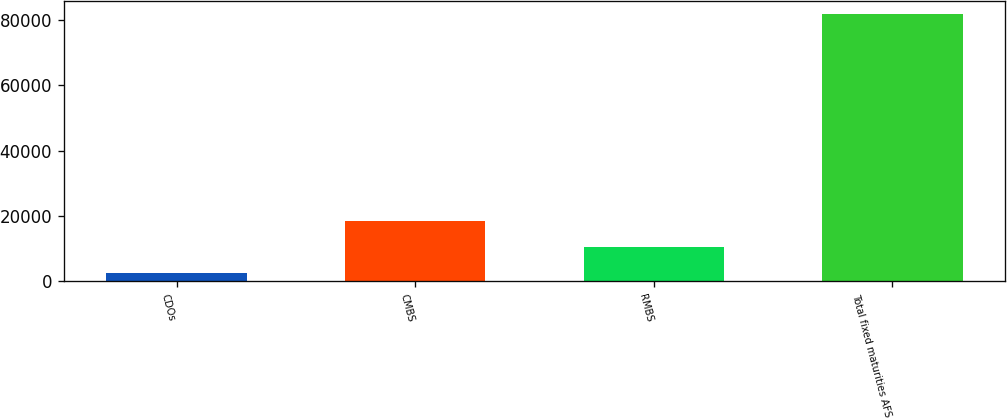Convert chart to OTSL. <chart><loc_0><loc_0><loc_500><loc_500><bar_chart><fcel>CDOs<fcel>CMBS<fcel>RMBS<fcel>Total fixed maturities AFS<nl><fcel>2487<fcel>18351.4<fcel>10419.2<fcel>81809<nl></chart> 